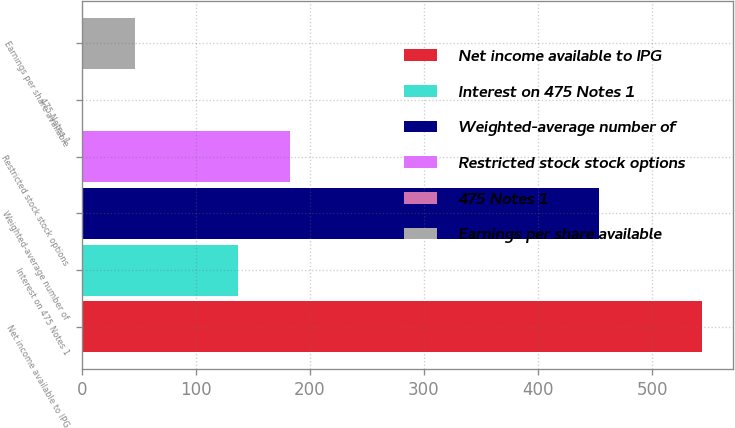Convert chart to OTSL. <chart><loc_0><loc_0><loc_500><loc_500><bar_chart><fcel>Net income available to IPG<fcel>Interest on 475 Notes 1<fcel>Weighted-average number of<fcel>Restricted stock stock options<fcel>475 Notes 1<fcel>Earnings per share available<nl><fcel>544.21<fcel>136.99<fcel>453.47<fcel>182.36<fcel>0.88<fcel>46.25<nl></chart> 